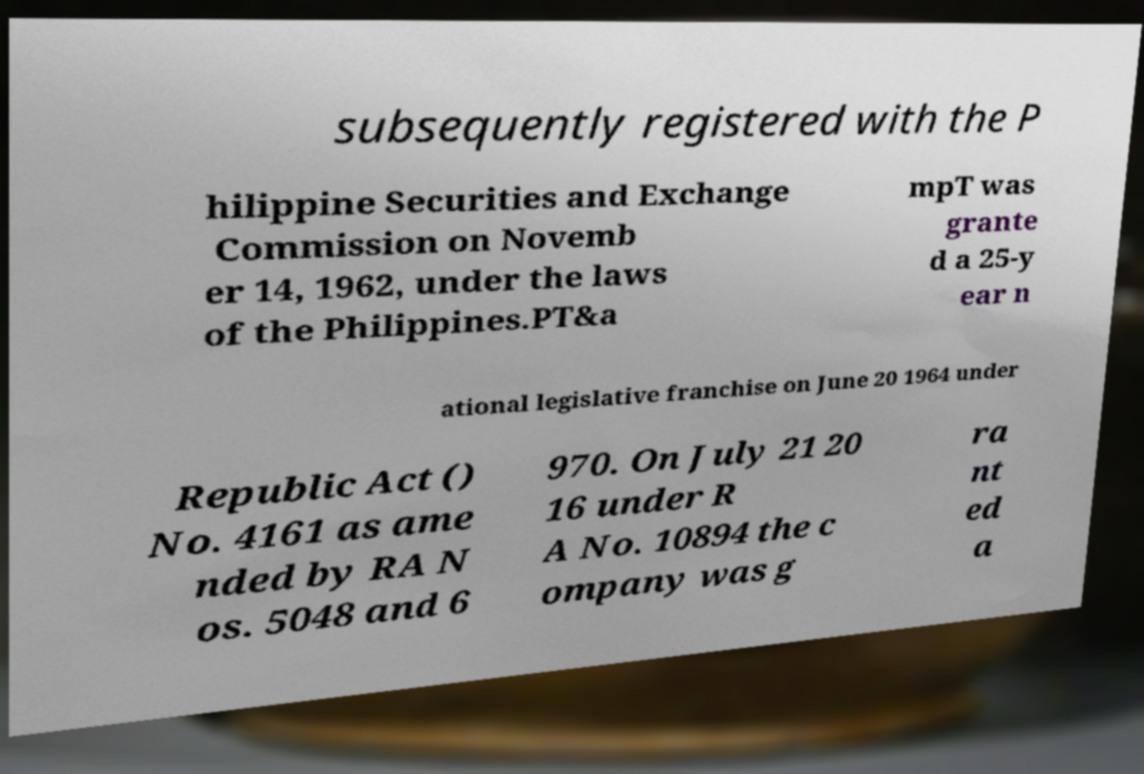Please read and relay the text visible in this image. What does it say? subsequently registered with the P hilippine Securities and Exchange Commission on Novemb er 14, 1962, under the laws of the Philippines.PT&a mpT was grante d a 25-y ear n ational legislative franchise on June 20 1964 under Republic Act () No. 4161 as ame nded by RA N os. 5048 and 6 970. On July 21 20 16 under R A No. 10894 the c ompany was g ra nt ed a 